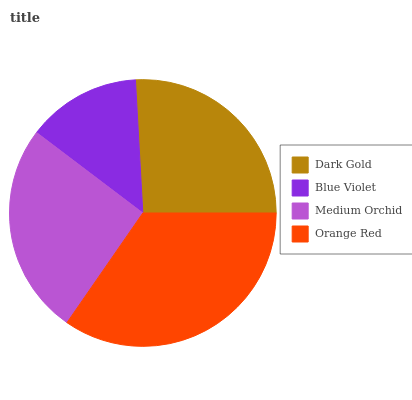Is Blue Violet the minimum?
Answer yes or no. Yes. Is Orange Red the maximum?
Answer yes or no. Yes. Is Medium Orchid the minimum?
Answer yes or no. No. Is Medium Orchid the maximum?
Answer yes or no. No. Is Medium Orchid greater than Blue Violet?
Answer yes or no. Yes. Is Blue Violet less than Medium Orchid?
Answer yes or no. Yes. Is Blue Violet greater than Medium Orchid?
Answer yes or no. No. Is Medium Orchid less than Blue Violet?
Answer yes or no. No. Is Dark Gold the high median?
Answer yes or no. Yes. Is Medium Orchid the low median?
Answer yes or no. Yes. Is Medium Orchid the high median?
Answer yes or no. No. Is Blue Violet the low median?
Answer yes or no. No. 